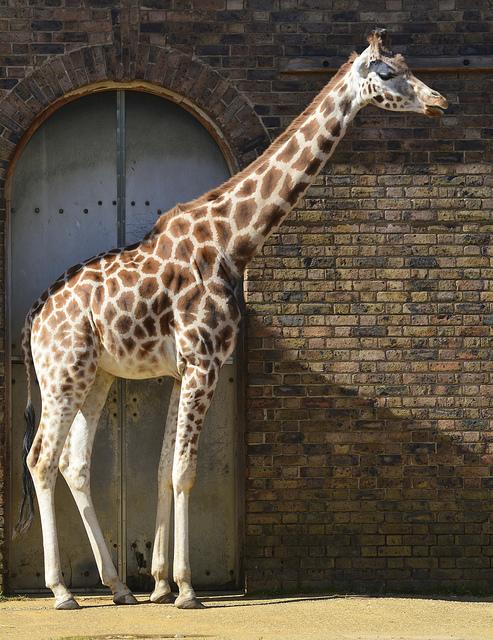Are all four of the giraffe's feet planted on the ground?
Be succinct. Yes. In what way does the giraffe and the wall match?
Answer briefly. Brown spots match. Is the giraffe planning to go through this door?
Concise answer only. No. 